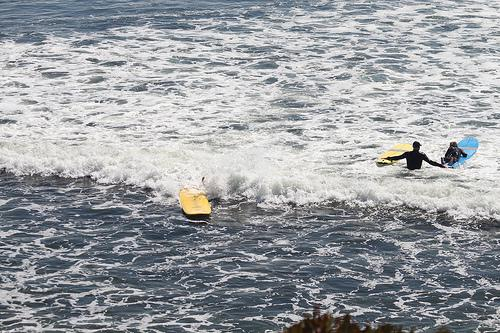Question: why are they in the water?
Choices:
A. Swimming.
B. Surfing.
C. Playing.
D. Cooling off.
Answer with the letter. Answer: B Question: what is the weather like?
Choices:
A. Sunny.
B. Clear.
C. Overcast.
D. Rainy.
Answer with the letter. Answer: A Question: what season is it?
Choices:
A. Summer.
B. Winter.
C. Spring.
D. Fall.
Answer with the letter. Answer: A Question: where is this scene?
Choices:
A. Mountains.
B. Plains.
C. City.
D. Beach.
Answer with the letter. Answer: D Question: where are they surfing?
Choices:
A. In a wave pool at the amusement park.
B. Water.
C. In a wave pool on a ship.
D. In their dreams.
Answer with the letter. Answer: B 